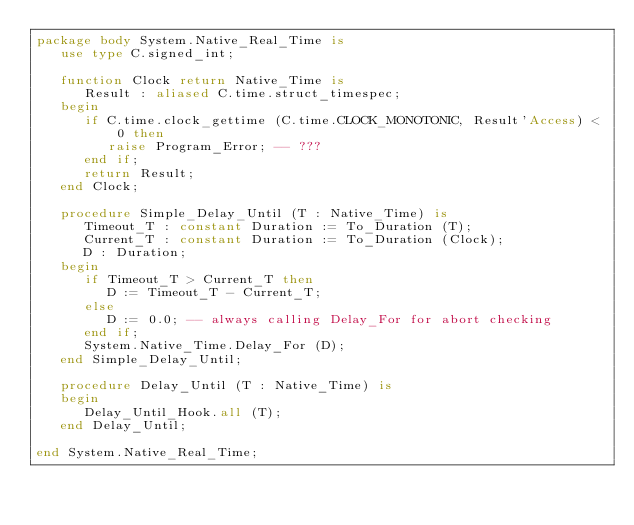Convert code to text. <code><loc_0><loc_0><loc_500><loc_500><_Ada_>package body System.Native_Real_Time is
   use type C.signed_int;

   function Clock return Native_Time is
      Result : aliased C.time.struct_timespec;
   begin
      if C.time.clock_gettime (C.time.CLOCK_MONOTONIC, Result'Access) < 0 then
         raise Program_Error; -- ???
      end if;
      return Result;
   end Clock;

   procedure Simple_Delay_Until (T : Native_Time) is
      Timeout_T : constant Duration := To_Duration (T);
      Current_T : constant Duration := To_Duration (Clock);
      D : Duration;
   begin
      if Timeout_T > Current_T then
         D := Timeout_T - Current_T;
      else
         D := 0.0; -- always calling Delay_For for abort checking
      end if;
      System.Native_Time.Delay_For (D);
   end Simple_Delay_Until;

   procedure Delay_Until (T : Native_Time) is
   begin
      Delay_Until_Hook.all (T);
   end Delay_Until;

end System.Native_Real_Time;
</code> 